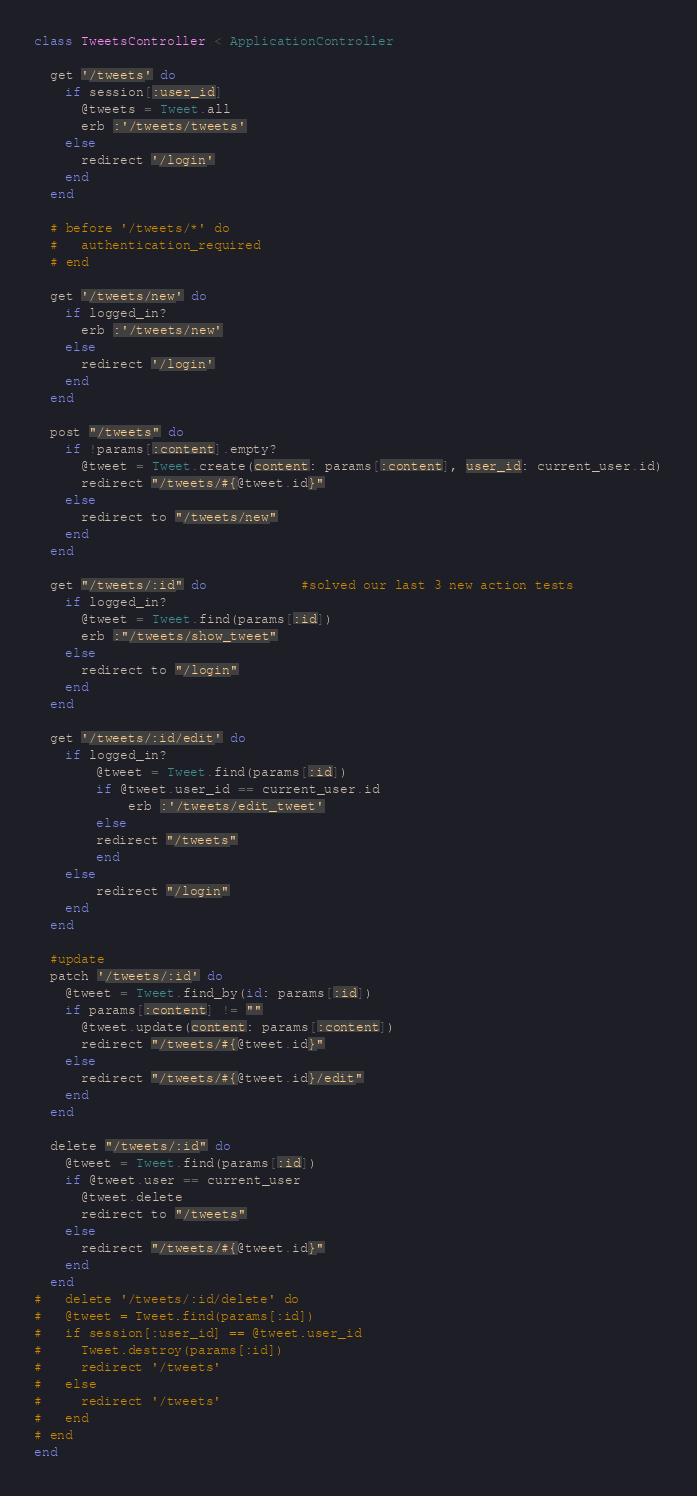Convert code to text. <code><loc_0><loc_0><loc_500><loc_500><_Ruby_>class TweetsController < ApplicationController

  get '/tweets' do
    if session[:user_id]
      @tweets = Tweet.all
      erb :'/tweets/tweets'
    else
      redirect '/login'
    end
  end

  # before '/tweets/*' do
  #   authentication_required
  # end

  get '/tweets/new' do
    if logged_in?
      erb :'/tweets/new'
    else
      redirect '/login'
    end
  end

  post "/tweets" do
    if !params[:content].empty?
      @tweet = Tweet.create(content: params[:content], user_id: current_user.id)
      redirect "/tweets/#{@tweet.id}"
    else
      redirect to "/tweets/new"
    end
  end

  get "/tweets/:id" do            #solved our last 3 new action tests
    if logged_in?
      @tweet = Tweet.find(params[:id])
      erb :"/tweets/show_tweet"
    else
      redirect to "/login"
    end
  end

  get '/tweets/:id/edit' do
    if logged_in?
        @tweet = Tweet.find(params[:id])
        if @tweet.user_id == current_user.id
            erb :'/tweets/edit_tweet'
        else
        redirect "/tweets"
        end
    else
        redirect "/login"
    end
  end

  #update
  patch '/tweets/:id' do
    @tweet = Tweet.find_by(id: params[:id])
    if params[:content] != ""
      @tweet.update(content: params[:content])
      redirect "/tweets/#{@tweet.id}"
    else
      redirect "/tweets/#{@tweet.id}/edit"
    end
  end

  delete "/tweets/:id" do
    @tweet = Tweet.find(params[:id])
    if @tweet.user == current_user
      @tweet.delete
      redirect to "/tweets"
    else
      redirect "/tweets/#{@tweet.id}"
    end
  end
#   delete '/tweets/:id/delete' do
#   @tweet = Tweet.find(params[:id])
#   if session[:user_id] == @tweet.user_id
#     Tweet.destroy(params[:id])
#     redirect '/tweets'
#   else
#     redirect '/tweets'
#   end
# end
end
</code> 